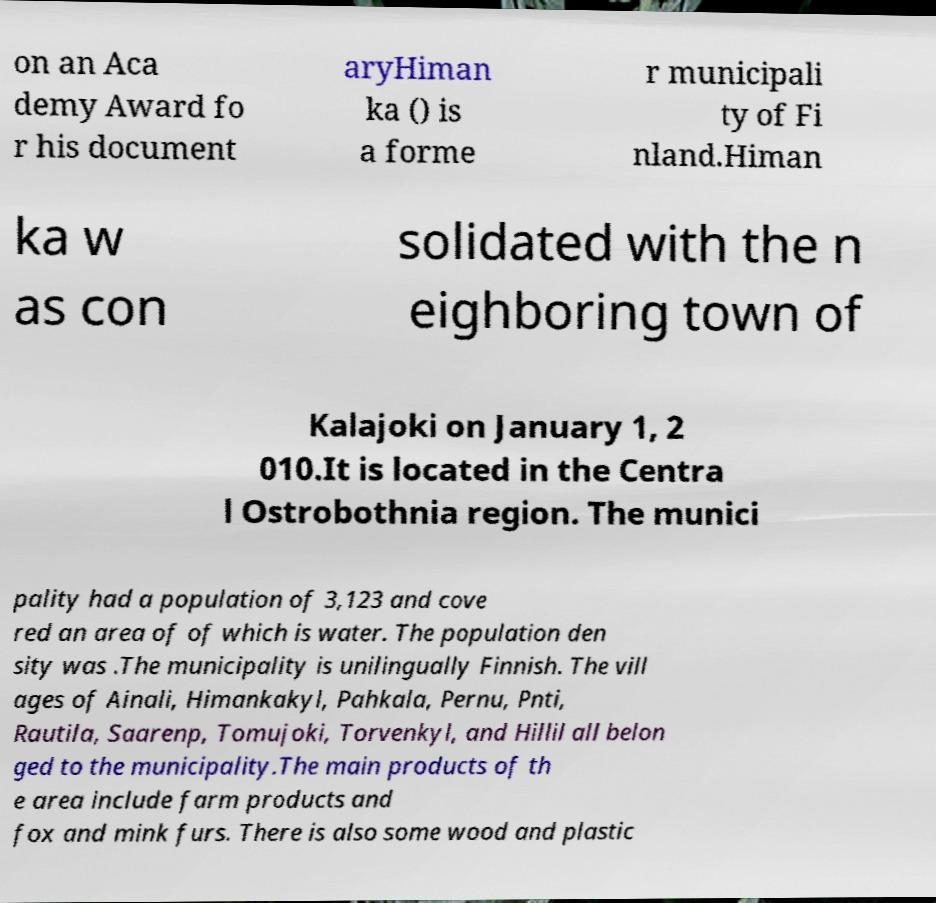There's text embedded in this image that I need extracted. Can you transcribe it verbatim? on an Aca demy Award fo r his document aryHiman ka () is a forme r municipali ty of Fi nland.Himan ka w as con solidated with the n eighboring town of Kalajoki on January 1, 2 010.It is located in the Centra l Ostrobothnia region. The munici pality had a population of 3,123 and cove red an area of of which is water. The population den sity was .The municipality is unilingually Finnish. The vill ages of Ainali, Himankakyl, Pahkala, Pernu, Pnti, Rautila, Saarenp, Tomujoki, Torvenkyl, and Hillil all belon ged to the municipality.The main products of th e area include farm products and fox and mink furs. There is also some wood and plastic 